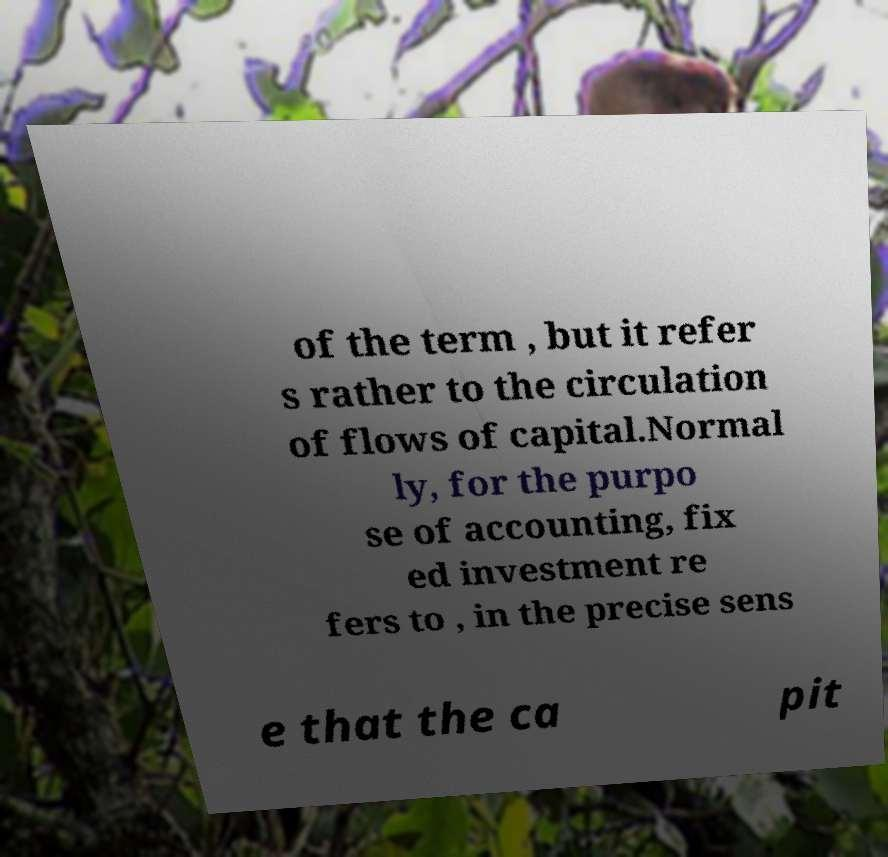What messages or text are displayed in this image? I need them in a readable, typed format. of the term , but it refer s rather to the circulation of flows of capital.Normal ly, for the purpo se of accounting, fix ed investment re fers to , in the precise sens e that the ca pit 